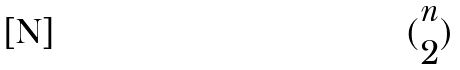<formula> <loc_0><loc_0><loc_500><loc_500>( \begin{matrix} n \\ 2 \end{matrix} )</formula> 